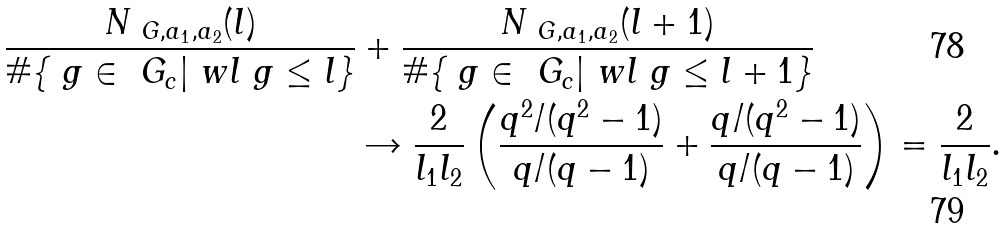<formula> <loc_0><loc_0><loc_500><loc_500>\frac { N _ { \ G , a _ { 1 } , a _ { 2 } } ( l ) } { \# \{ \ g \in \ G _ { c } | \ w l \ g \leq l \} } & + \frac { N _ { \ G , a _ { 1 } , a _ { 2 } } ( l + 1 ) } { \# \{ \ g \in \ G _ { c } | \ w l \ g \leq l + 1 \} } \\ & \rightarrow \frac { 2 } { l _ { 1 } l _ { 2 } } \left ( \frac { q ^ { 2 } / ( q ^ { 2 } - 1 ) } { q / ( q - 1 ) } + \frac { q / ( q ^ { 2 } - 1 ) } { q / ( q - 1 ) } \right ) = \frac { 2 } { l _ { 1 } l _ { 2 } } .</formula> 